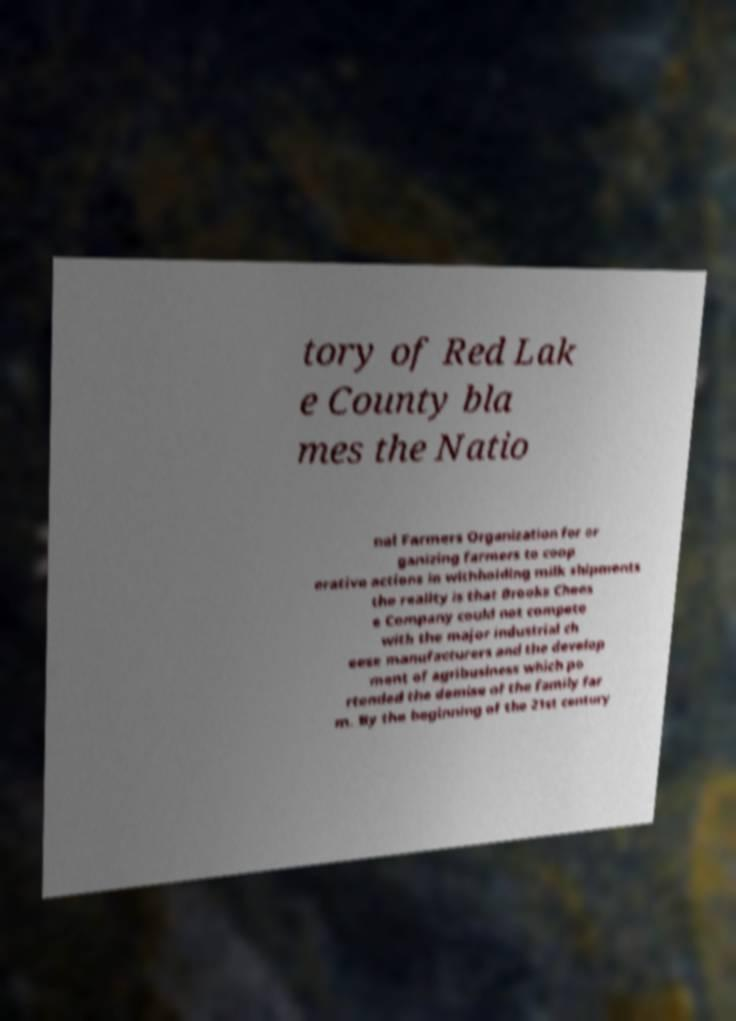Please read and relay the text visible in this image. What does it say? tory of Red Lak e County bla mes the Natio nal Farmers Organization for or ganizing farmers to coop erative actions in withholding milk shipments the reality is that Brooks Chees e Company could not compete with the major industrial ch eese manufacturers and the develop ment of agribusiness which po rtended the demise of the family far m. By the beginning of the 21st century 